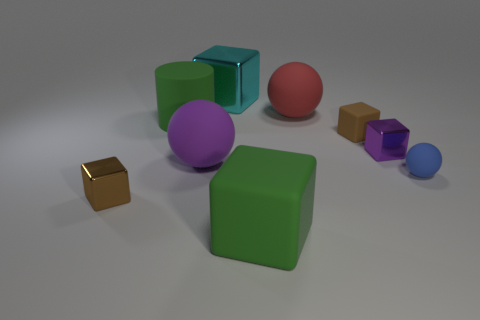What textures can be observed on the surfaces of the objects in the image? The objects exhibit a variety of textures. The large green cube and the smaller blue one have a matte finish. The large purple sphere has a slightly reflective matte texture, while the smaller red sphere seems to have a smooth, almost shiny surface. The gold cube has a reflective metallic texture, distinguishable from the other objects. 